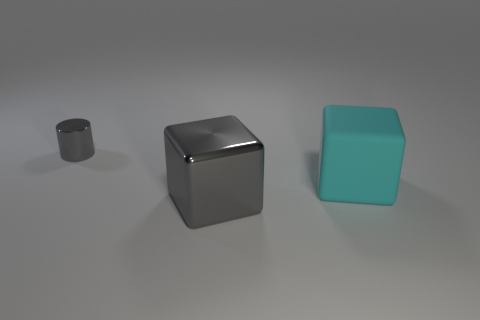What size is the cylinder that is the same color as the big shiny object?
Keep it short and to the point. Small. Are there more large cyan matte things that are on the right side of the cyan matte block than big rubber things?
Offer a terse response. No. Do the tiny gray object and the cyan matte object have the same shape?
Your answer should be compact. No. How many other large gray cubes have the same material as the gray block?
Your response must be concise. 0. The other gray thing that is the same shape as the big rubber object is what size?
Give a very brief answer. Large. Do the shiny block and the cyan matte thing have the same size?
Provide a short and direct response. Yes. What shape is the gray object that is on the left side of the metallic thing that is in front of the big block that is right of the gray metal block?
Your answer should be very brief. Cylinder. There is a big metallic thing that is the same shape as the rubber object; what color is it?
Provide a short and direct response. Gray. How big is the thing that is both behind the large gray metallic block and on the left side of the big cyan object?
Make the answer very short. Small. How many large gray metal cubes are behind the large cube to the right of the metal thing in front of the tiny metallic object?
Provide a short and direct response. 0. 